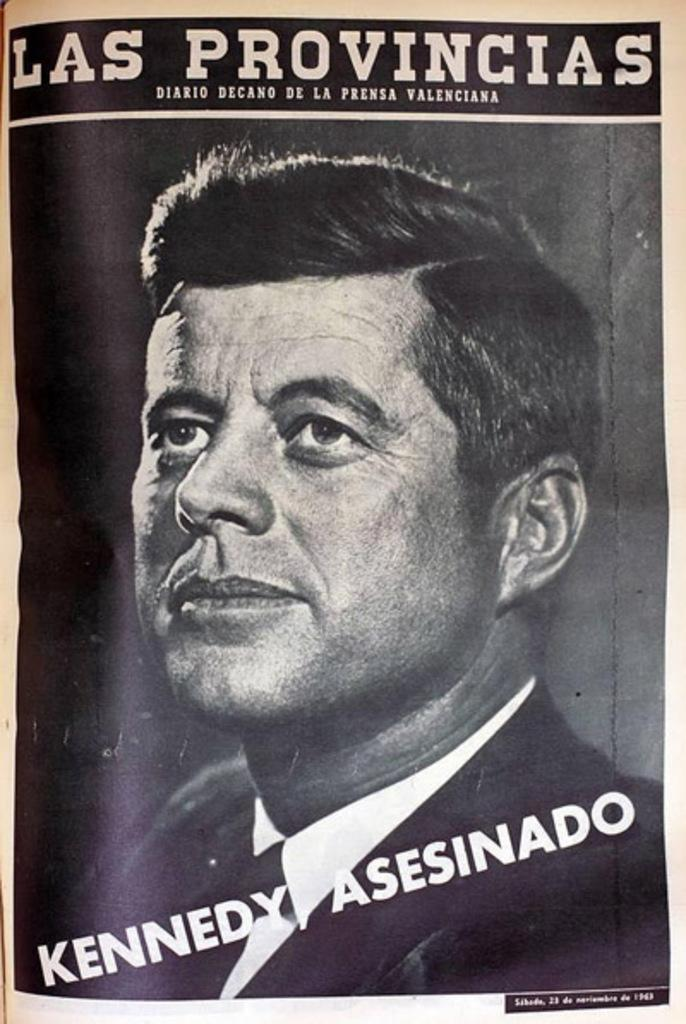<image>
Relay a brief, clear account of the picture shown. Magazine cover showing President Kennedy  and the words "Kennedy Asesinado". 